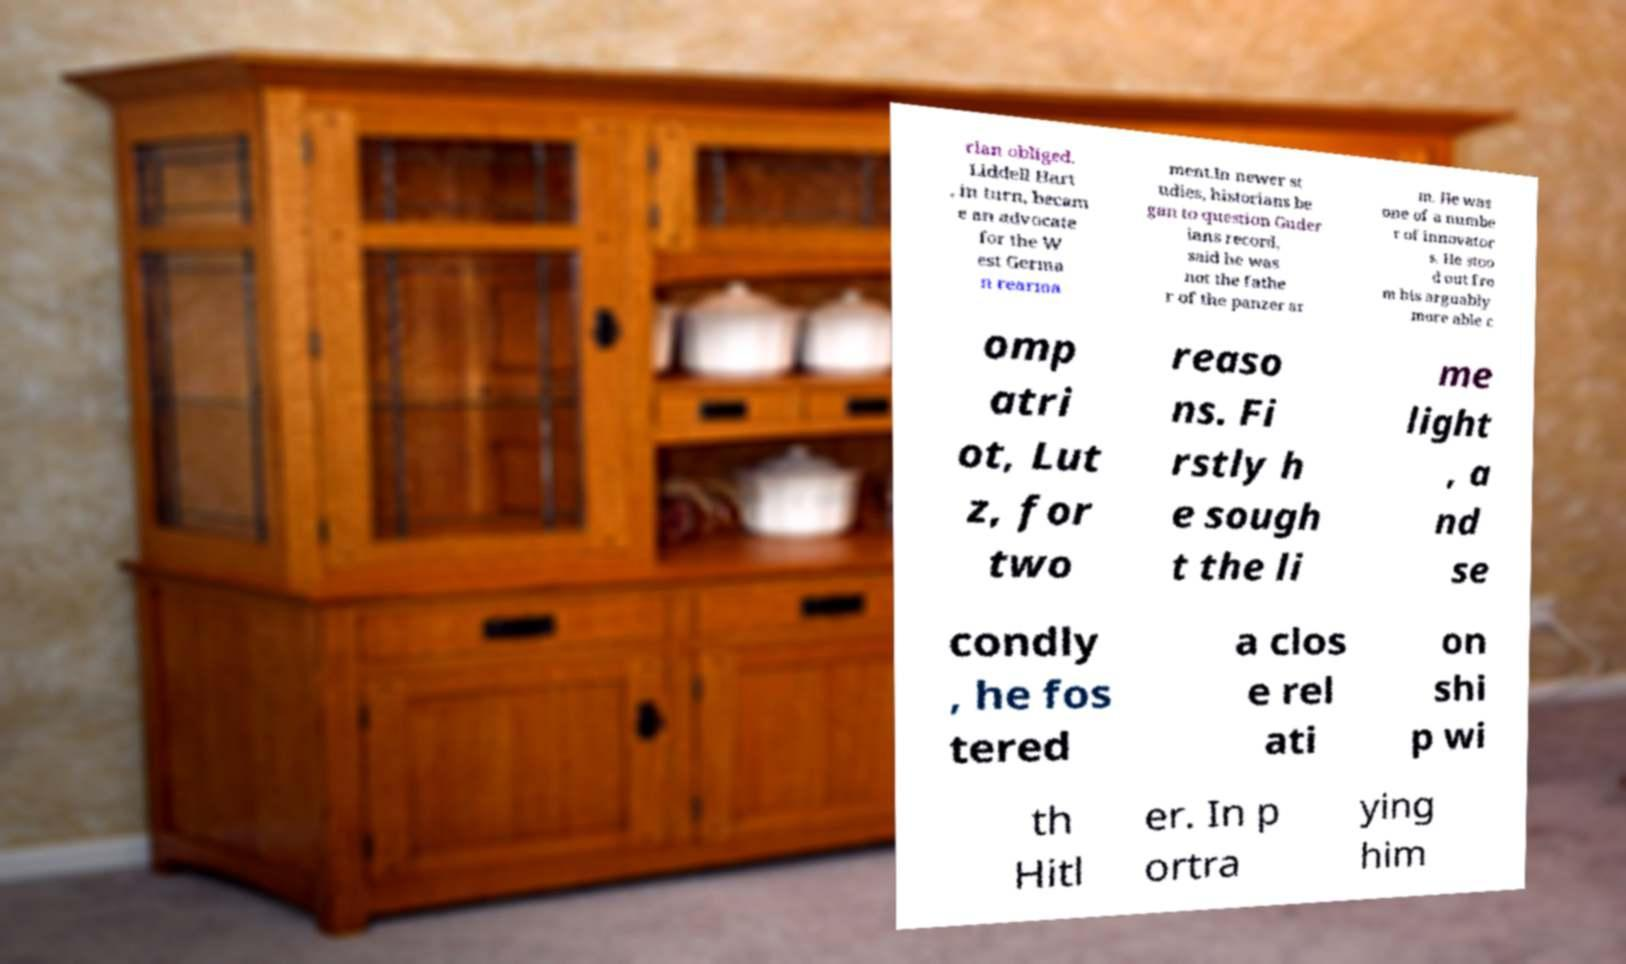Could you assist in decoding the text presented in this image and type it out clearly? rian obliged. Liddell Hart , in turn, becam e an advocate for the W est Germa n rearma ment.In newer st udies, historians be gan to question Guder ians record, said he was not the fathe r of the panzer ar m. He was one of a numbe r of innovator s. He stoo d out fro m his arguably more able c omp atri ot, Lut z, for two reaso ns. Fi rstly h e sough t the li me light , a nd se condly , he fos tered a clos e rel ati on shi p wi th Hitl er. In p ortra ying him 